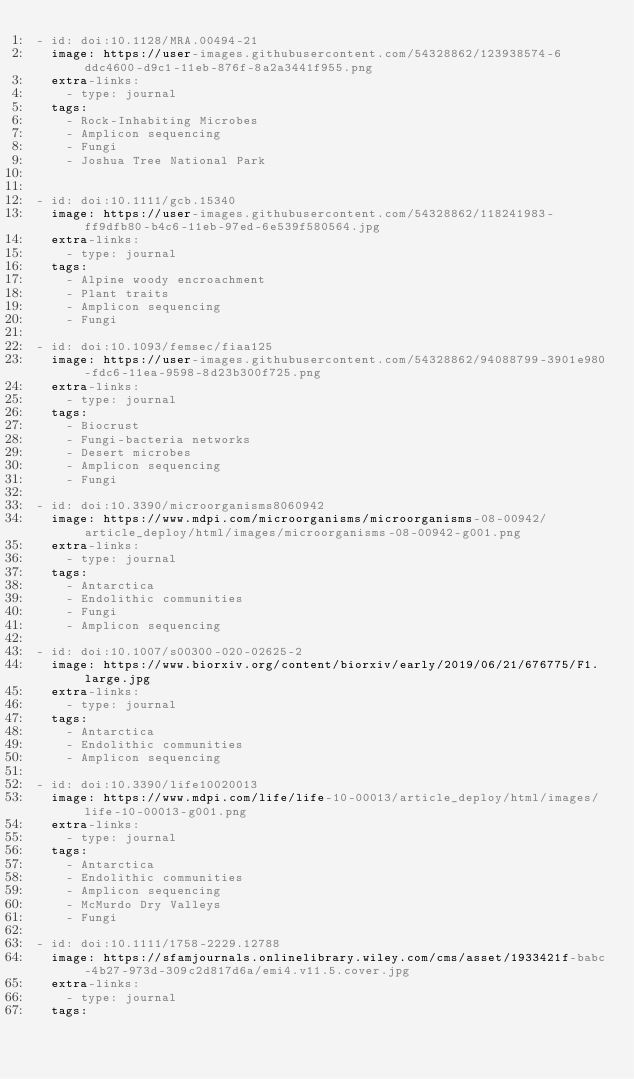<code> <loc_0><loc_0><loc_500><loc_500><_YAML_>- id: doi:10.1128/MRA.00494-21
  image: https://user-images.githubusercontent.com/54328862/123938574-6ddc4600-d9c1-11eb-876f-8a2a3441f955.png
  extra-links:
    - type: journal
  tags:
    - Rock-Inhabiting Microbes
    - Amplicon sequencing
    - Fungi
    - Joshua Tree National Park


- id: doi:10.1111/gcb.15340
  image: https://user-images.githubusercontent.com/54328862/118241983-ff9dfb80-b4c6-11eb-97ed-6e539f580564.jpg
  extra-links:
    - type: journal
  tags:
    - Alpine woody encroachment
    - Plant traits
    - Amplicon sequencing
    - Fungi

- id: doi:10.1093/femsec/fiaa125
  image: https://user-images.githubusercontent.com/54328862/94088799-3901e980-fdc6-11ea-9598-8d23b300f725.png
  extra-links:
    - type: journal
  tags:
    - Biocrust
    - Fungi-bacteria networks
    - Desert microbes
    - Amplicon sequencing
    - Fungi

- id: doi:10.3390/microorganisms8060942
  image: https://www.mdpi.com/microorganisms/microorganisms-08-00942/article_deploy/html/images/microorganisms-08-00942-g001.png
  extra-links:
    - type: journal
  tags:
    - Antarctica
    - Endolithic communities
    - Fungi
    - Amplicon sequencing

- id: doi:10.1007/s00300-020-02625-2
  image: https://www.biorxiv.org/content/biorxiv/early/2019/06/21/676775/F1.large.jpg
  extra-links:
    - type: journal
  tags:
    - Antarctica
    - Endolithic communities
    - Amplicon sequencing

- id: doi:10.3390/life10020013
  image: https://www.mdpi.com/life/life-10-00013/article_deploy/html/images/life-10-00013-g001.png
  extra-links:
    - type: journal
  tags:
    - Antarctica
    - Endolithic communities
    - Amplicon sequencing
    - McMurdo Dry Valleys
    - Fungi

- id: doi:10.1111/1758-2229.12788
  image: https://sfamjournals.onlinelibrary.wiley.com/cms/asset/1933421f-babc-4b27-973d-309c2d817d6a/emi4.v11.5.cover.jpg
  extra-links:
    - type: journal
  tags:</code> 